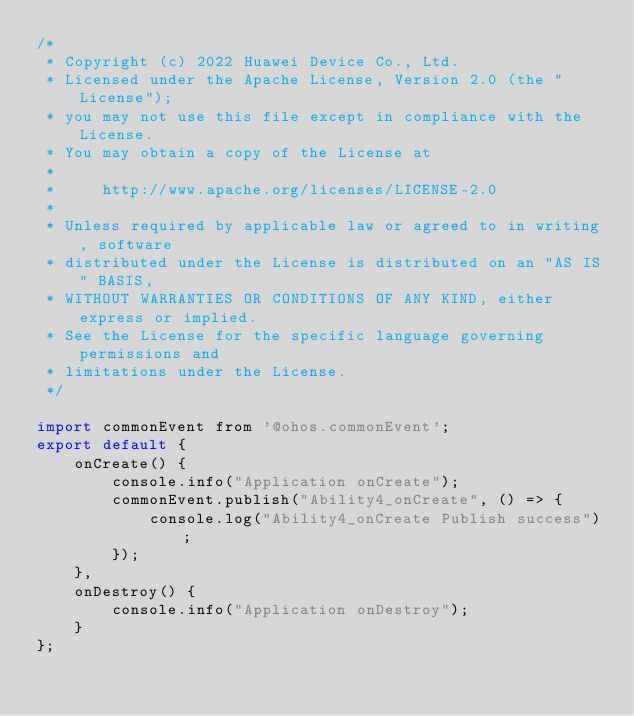<code> <loc_0><loc_0><loc_500><loc_500><_JavaScript_>/*
 * Copyright (c) 2022 Huawei Device Co., Ltd.
 * Licensed under the Apache License, Version 2.0 (the "License");
 * you may not use this file except in compliance with the License.
 * You may obtain a copy of the License at
 *
 *     http://www.apache.org/licenses/LICENSE-2.0
 *
 * Unless required by applicable law or agreed to in writing, software
 * distributed under the License is distributed on an "AS IS" BASIS,
 * WITHOUT WARRANTIES OR CONDITIONS OF ANY KIND, either express or implied.
 * See the License for the specific language governing permissions and
 * limitations under the License.
 */

import commonEvent from '@ohos.commonEvent';
export default {
    onCreate() {
        console.info("Application onCreate");
        commonEvent.publish("Ability4_onCreate", () => {
            console.log("Ability4_onCreate Publish success");
        });
    },
    onDestroy() {
        console.info("Application onDestroy");
    }
};
</code> 